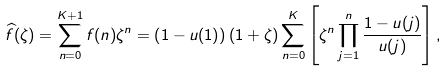Convert formula to latex. <formula><loc_0><loc_0><loc_500><loc_500>\widehat { f } ( \zeta ) = \sum ^ { K + 1 } _ { n = 0 } f ( n ) \zeta ^ { n } = \left ( 1 - u ( 1 ) \right ) ( 1 + \zeta ) \sum ^ { K } _ { n = 0 } \left [ \zeta ^ { n } \prod ^ { n } _ { j = 1 } \frac { 1 - u ( j ) } { u ( j ) } \right ] ,</formula> 